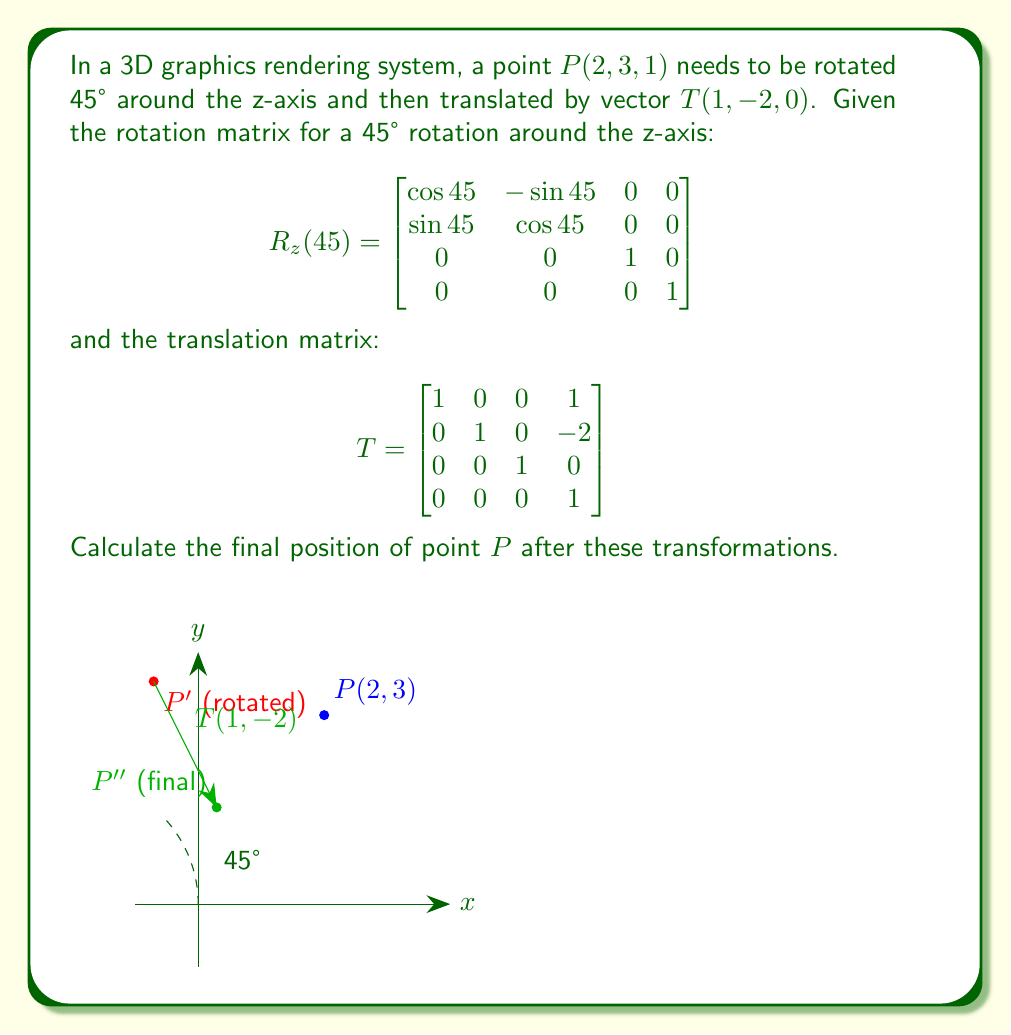Can you solve this math problem? Let's approach this step-by-step:

1) First, we need to represent the point $P(2, 3, 1)$ as a 4D homogeneous coordinate vector:

   $P = \begin{bmatrix} 2 \\ 3 \\ 1 \\ 1 \end{bmatrix}$

2) Next, we apply the rotation. We know that $\cos 45° = \sin 45° = \frac{\sqrt{2}}{2}$. So our rotation matrix is:

   $$R_z(45°) = \begin{bmatrix}
   \frac{\sqrt{2}}{2} & -\frac{\sqrt{2}}{2} & 0 & 0 \\
   \frac{\sqrt{2}}{2} & \frac{\sqrt{2}}{2} & 0 & 0 \\
   0 & 0 & 1 & 0 \\
   0 & 0 & 0 & 1
   \end{bmatrix}$$

3) We multiply the rotation matrix by our point:

   $$R_z(45°) \cdot P = \begin{bmatrix}
   \frac{\sqrt{2}}{2} & -\frac{\sqrt{2}}{2} & 0 & 0 \\
   \frac{\sqrt{2}}{2} & \frac{\sqrt{2}}{2} & 0 & 0 \\
   0 & 0 & 1 & 0 \\
   0 & 0 & 0 & 1
   \end{bmatrix} \cdot \begin{bmatrix} 2 \\ 3 \\ 1 \\ 1 \end{bmatrix}$$

   $$= \begin{bmatrix}
   2\frac{\sqrt{2}}{2} - 3\frac{\sqrt{2}}{2} \\
   2\frac{\sqrt{2}}{2} + 3\frac{\sqrt{2}}{2} \\
   1 \\
   1
   \end{bmatrix} = \begin{bmatrix}
   -\frac{\sqrt{2}}{2} \\
   5\frac{\sqrt{2}}{2} \\
   1 \\
   1
   \end{bmatrix}$$

4) Now we apply the translation by multiplying with the translation matrix:

   $$T \cdot (R_z(45°) \cdot P) = \begin{bmatrix}
   1 & 0 & 0 & 1 \\
   0 & 1 & 0 & -2 \\
   0 & 0 & 1 & 0 \\
   0 & 0 & 0 & 1
   \end{bmatrix} \cdot \begin{bmatrix}
   -\frac{\sqrt{2}}{2} \\
   5\frac{\sqrt{2}}{2} \\
   1 \\
   1
   \end{bmatrix}$$

   $$= \begin{bmatrix}
   -\frac{\sqrt{2}}{2} + 1 \\
   5\frac{\sqrt{2}}{2} - 2 \\
   1 \\
   1
   \end{bmatrix}$$

5) The final result is the point:

   $$P' = (-\frac{\sqrt{2}}{2} + 1, 5\frac{\sqrt{2}}{2} - 2, 1)$$
Answer: $(-\frac{\sqrt{2}}{2} + 1, 5\frac{\sqrt{2}}{2} - 2, 1)$ 